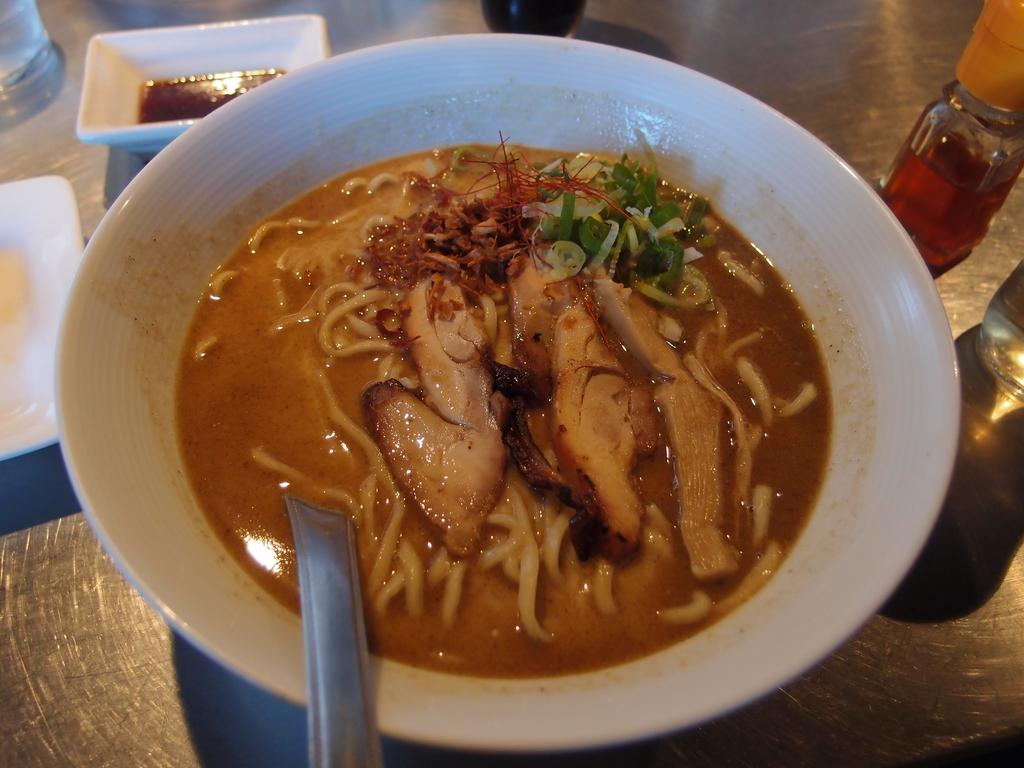What is the primary object on the platform in the image? There is a plate, a glass, a bowl with food items, a spoon, and a bottle on the platform in the image. What type of food items can be seen in the bowl? The bowl contains food items, but the specific type of food cannot be determined from the image. What utensil is used to eat the food in the bowl? There is a spoon in the bowl in the bowl in the image. What other objects are present on the platform? There are other objects on the platform, but their specific nature cannot be determined from the image. What is the acoustics like in the image? The image does not provide any information about the acoustics, as it focuses on objects placed on a platform. What type of frame surrounds the image? The image does not have a frame, as it is a digital representation of the scene. 